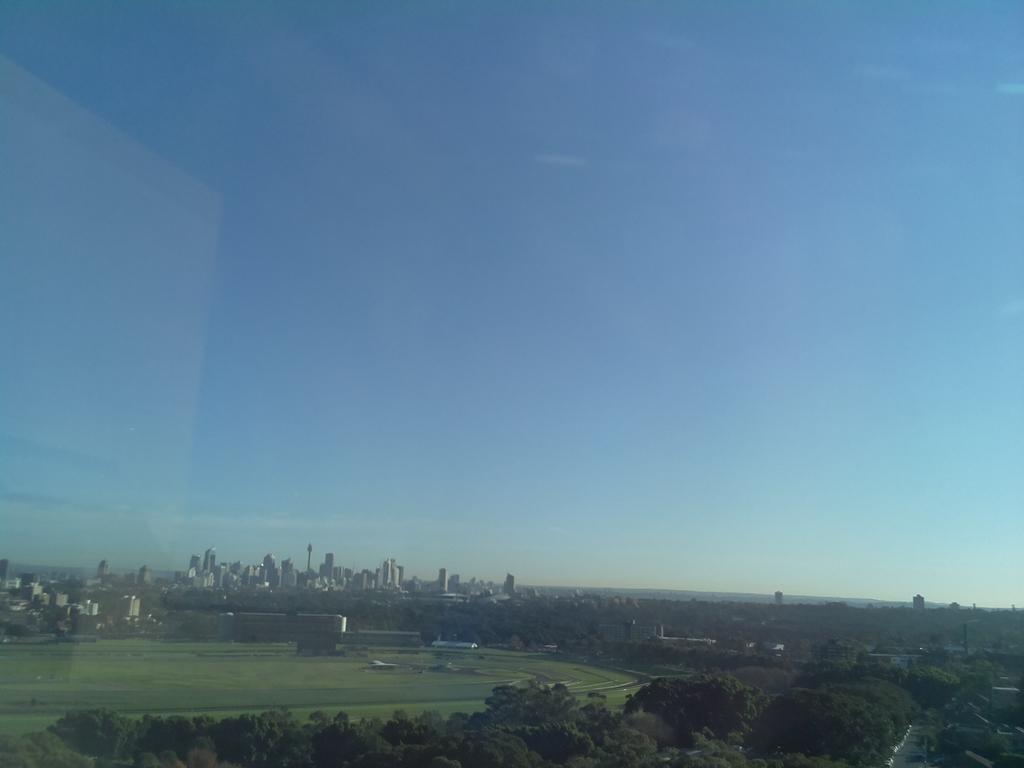Describe this image in one or two sentences. In this image, we can see some buildings, trees. We can see the ground with some grass and a few objects. We can also see the sky. 